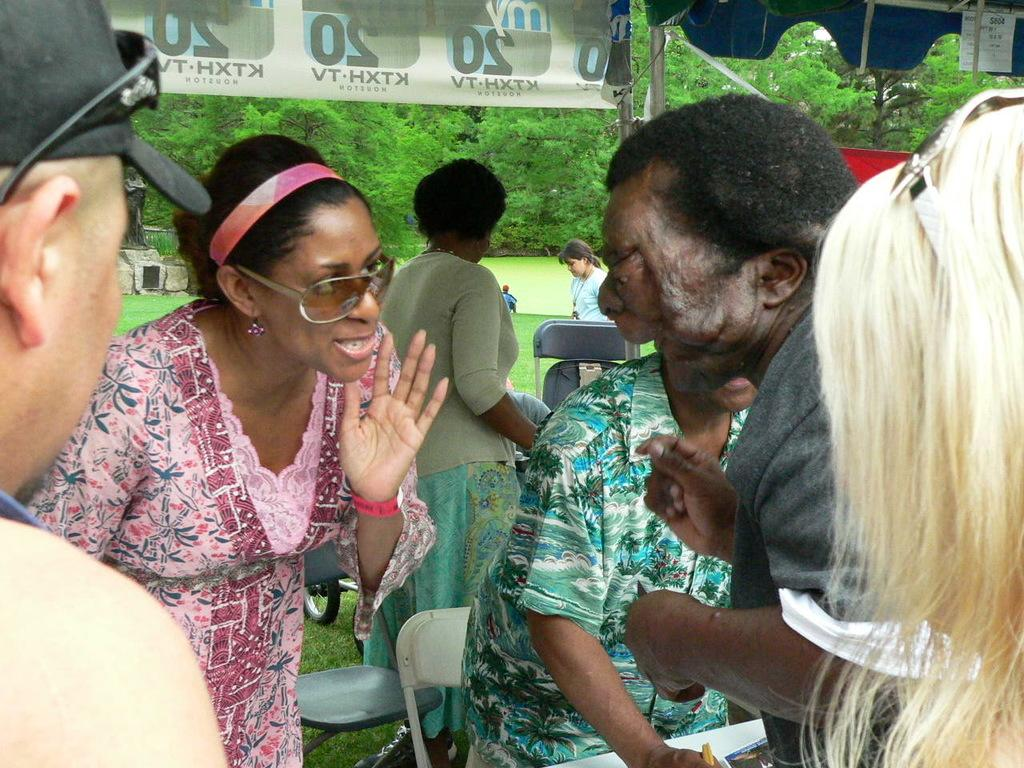What are the people in the image doing? The people in the image are standing and talking. What is the surface on which the chairs are placed? The chairs are placed on a grass surface in the image. What can be seen in the background of the image? There are trees visible in the background of the image. What type of straw is being used by the people in the image? There is no straw visible in the image; the people are standing and talking without any apparent use of straws. 